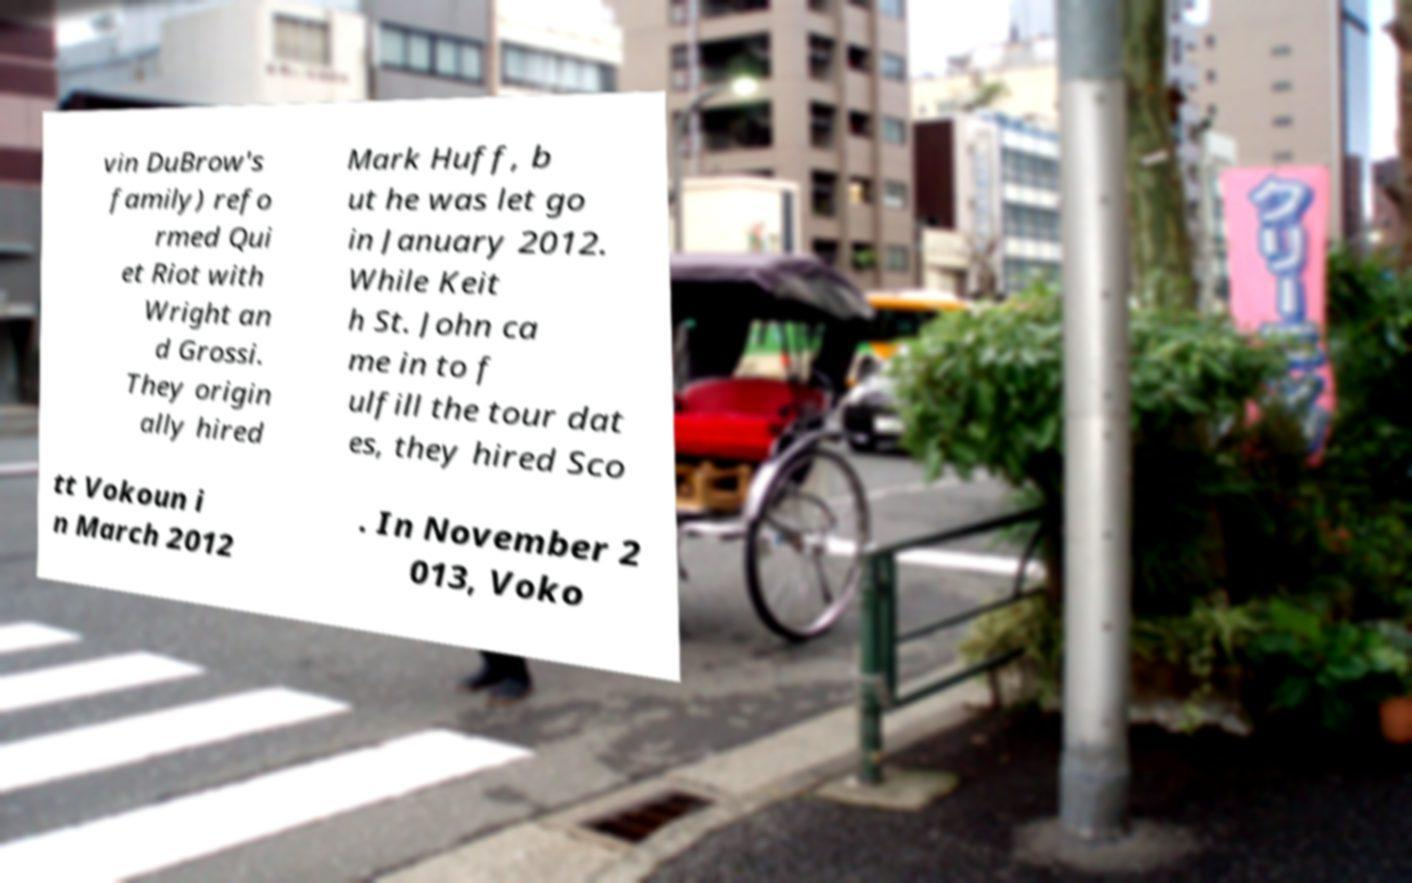Can you accurately transcribe the text from the provided image for me? vin DuBrow's family) refo rmed Qui et Riot with Wright an d Grossi. They origin ally hired Mark Huff, b ut he was let go in January 2012. While Keit h St. John ca me in to f ulfill the tour dat es, they hired Sco tt Vokoun i n March 2012 . In November 2 013, Voko 